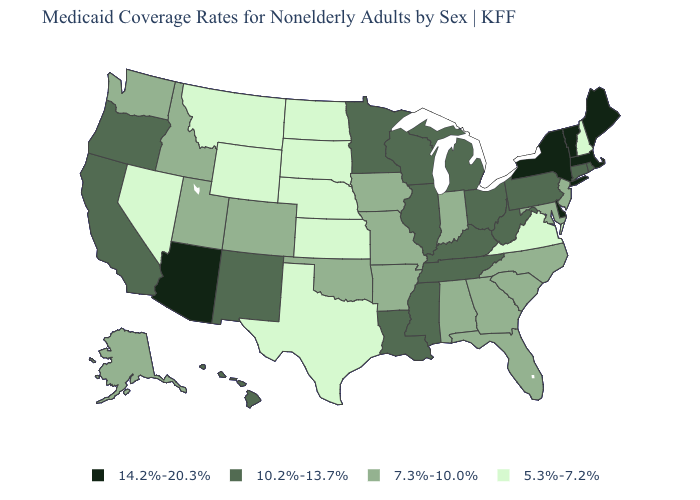Among the states that border Montana , which have the lowest value?
Give a very brief answer. North Dakota, South Dakota, Wyoming. Does Delaware have the highest value in the USA?
Short answer required. Yes. What is the highest value in states that border Minnesota?
Concise answer only. 10.2%-13.7%. What is the highest value in the USA?
Be succinct. 14.2%-20.3%. Name the states that have a value in the range 14.2%-20.3%?
Write a very short answer. Arizona, Delaware, Maine, Massachusetts, New York, Vermont. What is the value of Louisiana?
Be succinct. 10.2%-13.7%. Does New Jersey have the same value as Missouri?
Concise answer only. Yes. Does Nevada have the lowest value in the USA?
Write a very short answer. Yes. What is the highest value in the USA?
Concise answer only. 14.2%-20.3%. Name the states that have a value in the range 10.2%-13.7%?
Write a very short answer. California, Connecticut, Hawaii, Illinois, Kentucky, Louisiana, Michigan, Minnesota, Mississippi, New Mexico, Ohio, Oregon, Pennsylvania, Rhode Island, Tennessee, West Virginia, Wisconsin. Which states hav the highest value in the West?
Write a very short answer. Arizona. Does Montana have the lowest value in the West?
Quick response, please. Yes. How many symbols are there in the legend?
Concise answer only. 4. Name the states that have a value in the range 14.2%-20.3%?
Give a very brief answer. Arizona, Delaware, Maine, Massachusetts, New York, Vermont. 